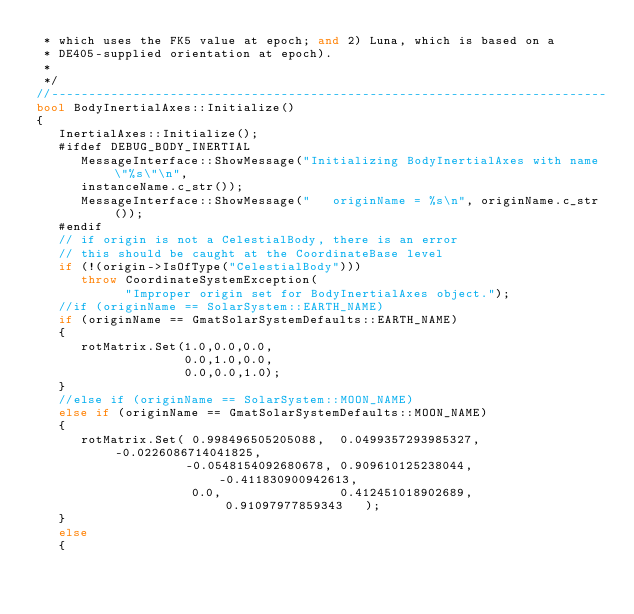<code> <loc_0><loc_0><loc_500><loc_500><_C++_> * which uses the FK5 value at epoch; and 2) Luna, which is based on a
 * DE405-supplied orientation at epoch).
 *
 */
//---------------------------------------------------------------------------
bool BodyInertialAxes::Initialize()
{
   InertialAxes::Initialize();
   #ifdef DEBUG_BODY_INERTIAL
      MessageInterface::ShowMessage("Initializing BodyInertialAxes with name \"%s\"\n",
      instanceName.c_str());
      MessageInterface::ShowMessage("   originName = %s\n", originName.c_str());
   #endif
   // if origin is not a CelestialBody, there is an error
   // this should be caught at the CoordinateBase level
   if (!(origin->IsOfType("CelestialBody")))
      throw CoordinateSystemException(
            "Improper origin set for BodyInertialAxes object.");
   //if (originName == SolarSystem::EARTH_NAME)
   if (originName == GmatSolarSystemDefaults::EARTH_NAME)
   {
      rotMatrix.Set(1.0,0.0,0.0,
                    0.0,1.0,0.0,
                    0.0,0.0,1.0);
   }
   //else if (originName == SolarSystem::MOON_NAME)
   else if (originName == GmatSolarSystemDefaults::MOON_NAME)
   {
      rotMatrix.Set( 0.998496505205088,  0.0499357293985327, -0.0226086714041825,
                    -0.0548154092680678, 0.909610125238044,  -0.411830900942613,
                     0.0,                0.412451018902689,   0.91097977859343   );
   }
   else
   {</code> 